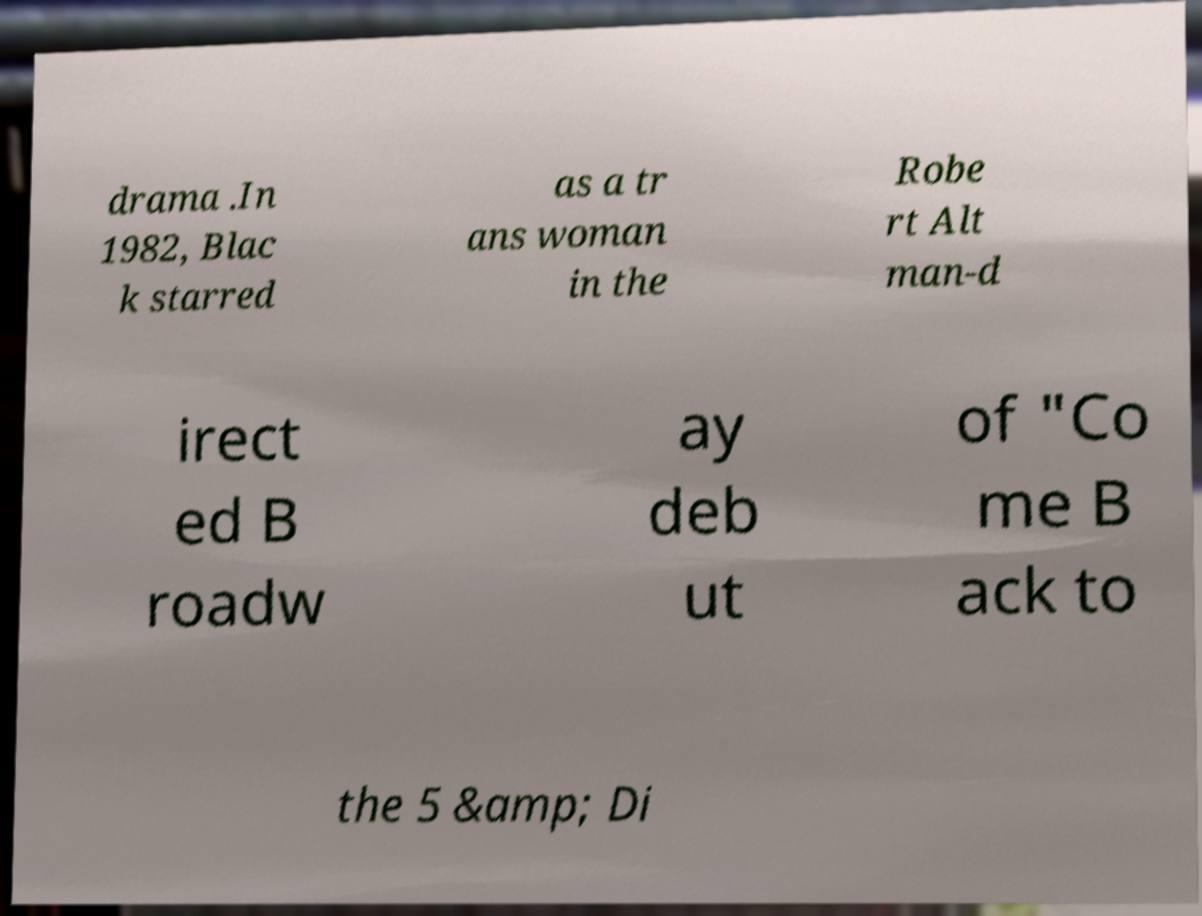Please read and relay the text visible in this image. What does it say? drama .In 1982, Blac k starred as a tr ans woman in the Robe rt Alt man-d irect ed B roadw ay deb ut of "Co me B ack to the 5 &amp; Di 